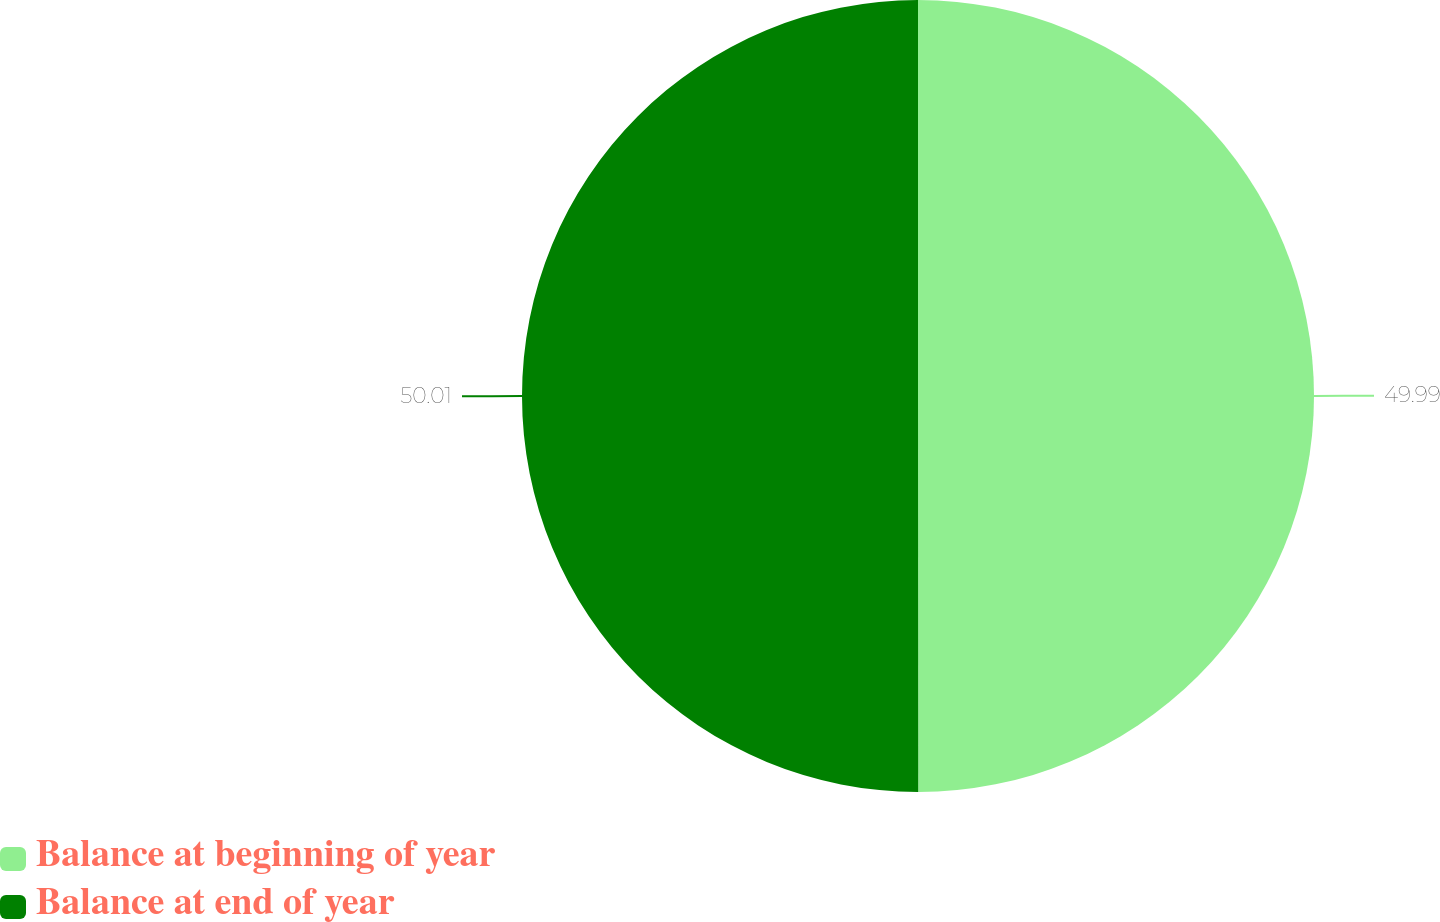<chart> <loc_0><loc_0><loc_500><loc_500><pie_chart><fcel>Balance at beginning of year<fcel>Balance at end of year<nl><fcel>49.99%<fcel>50.01%<nl></chart> 